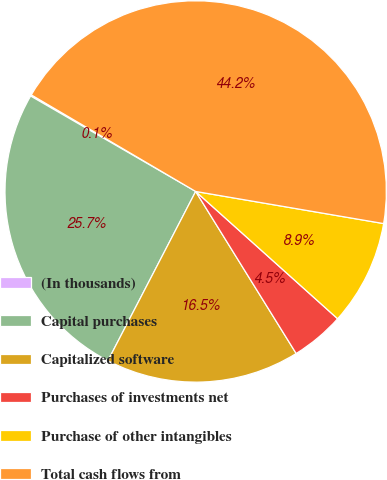Convert chart to OTSL. <chart><loc_0><loc_0><loc_500><loc_500><pie_chart><fcel>(In thousands)<fcel>Capital purchases<fcel>Capitalized software<fcel>Purchases of investments net<fcel>Purchase of other intangibles<fcel>Total cash flows from<nl><fcel>0.11%<fcel>25.73%<fcel>16.45%<fcel>4.53%<fcel>8.94%<fcel>44.24%<nl></chart> 